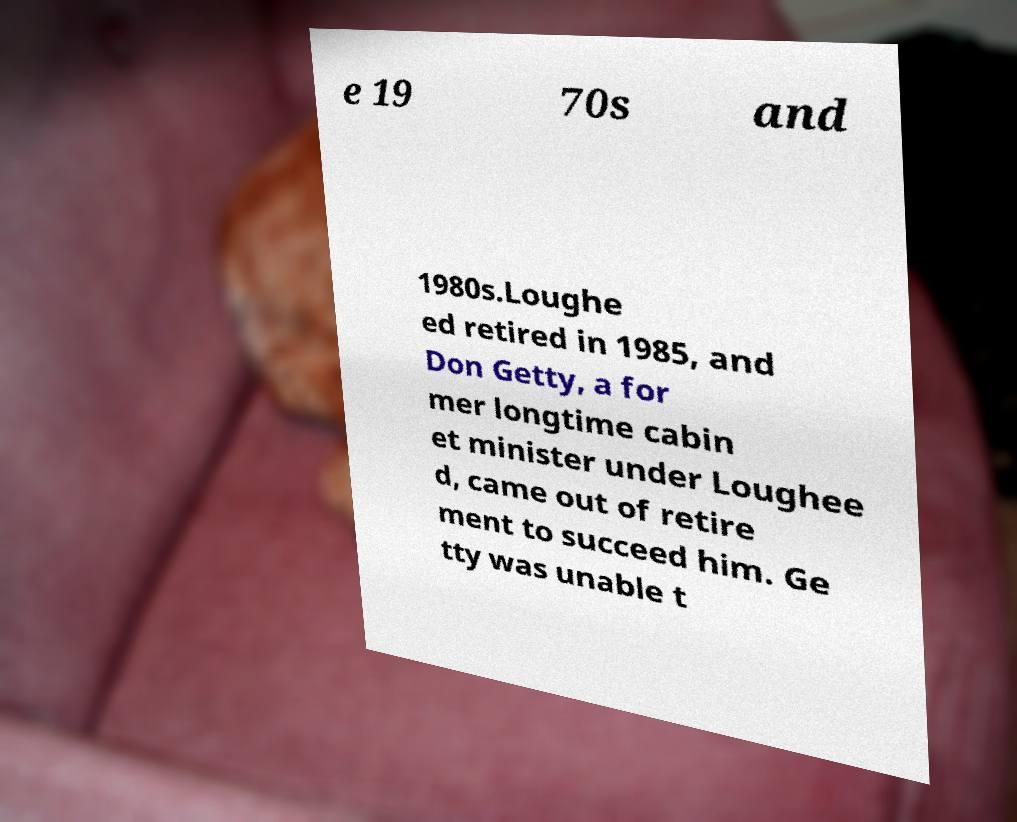Could you assist in decoding the text presented in this image and type it out clearly? e 19 70s and 1980s.Loughe ed retired in 1985, and Don Getty, a for mer longtime cabin et minister under Loughee d, came out of retire ment to succeed him. Ge tty was unable t 